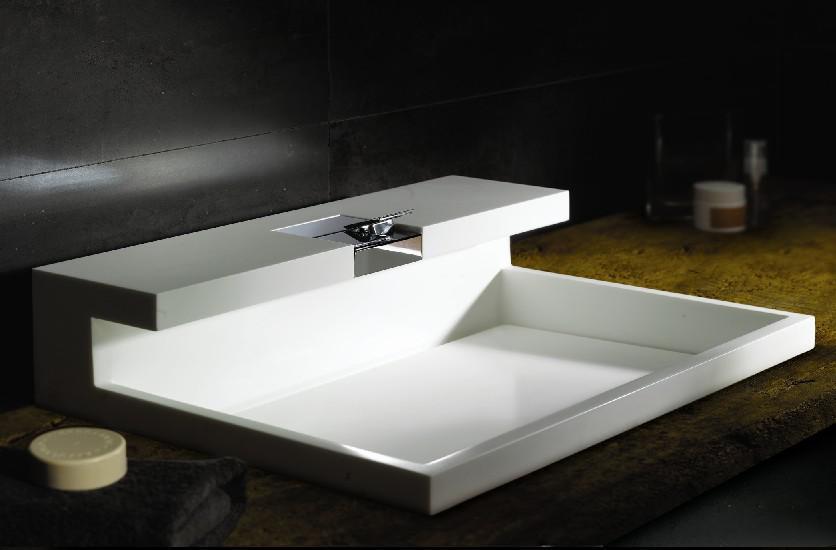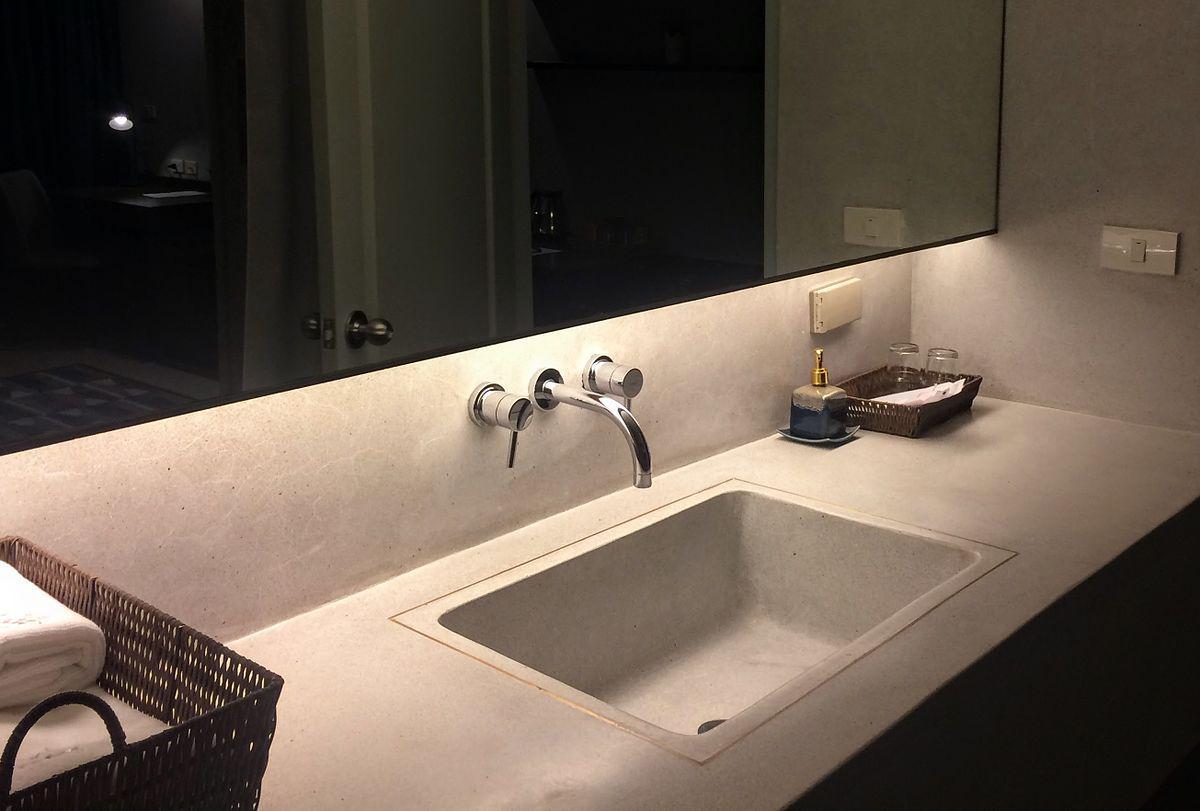The first image is the image on the left, the second image is the image on the right. Examine the images to the left and right. Is the description "One image shows a single sink and the other shows two adjacent sinks." accurate? Answer yes or no. No. The first image is the image on the left, the second image is the image on the right. Given the left and right images, does the statement "One image shows a single rectangular sink inset in a long white counter, and the other image features two white horizontal elements." hold true? Answer yes or no. Yes. 